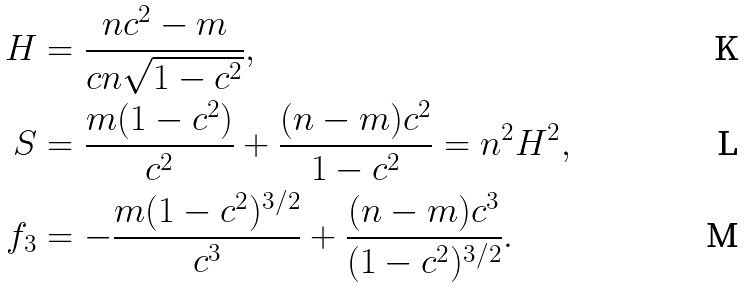<formula> <loc_0><loc_0><loc_500><loc_500>H & = \frac { n c ^ { 2 } - m } { c n \sqrt { 1 - c ^ { 2 } } } , \\ S & = \frac { m ( 1 - c ^ { 2 } ) } { c ^ { 2 } } + \frac { ( n - m ) c ^ { 2 } } { 1 - c ^ { 2 } } = n ^ { 2 } H ^ { 2 } , \\ f _ { 3 } & = - \frac { m ( 1 - c ^ { 2 } ) ^ { 3 / 2 } } { c ^ { 3 } } + \frac { ( n - m ) c ^ { 3 } } { ( 1 - c ^ { 2 } ) ^ { 3 / 2 } } .</formula> 